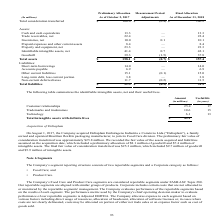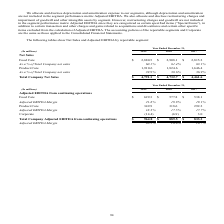From Sealed Air Corporation's financial document, What are the two reportable segments of the company? The document shows two values: Food Care and Product Care. From the document: "• Product Care. lian flexible packaging manufacturer, to join its Food Care division. The preliminary fair value of consideration transferred was appr..." Also, What do the tables show? The following tables show Net Sales and Adjusted EBITDA by reportable segment. The document states: "The following tables show Net Sales and Adjusted EBITDA by reportable segment:..." Also, What is the Adjusted EBITDA Margin for year 2019 for the whole company? According to the financial document, 20.1%. The relevant text states: "Adjusted EBITDA Margin 20.1% 18.8% 18.7%..." Also, can you calculate: What is the average EBITDA Margin for years 2017-2019 for the whole company? To answer this question, I need to perform calculations using the financial data. The calculation is: (20.1+18.8+18.7)/3, which equals 19.2 (percentage). This is based on the information: "Adjusted EBITDA Margin 20.1% 18.8% 18.7% Adjusted EBITDA Margin 20.1% 18.8% 18.7% Adjusted EBITDA Margin 20.1% 18.8% 18.7%..." The key data points involved are: 18.7, 18.8, 20.1. Also, can you calculate: What is the percentage change of  Total Company Net Sales from year 2018 to year 2019? To answer this question, I need to perform calculations using the financial data. The calculation is: (4,791.1-4,732.7)/4,732.7, which equals 1.23 (percentage). This is based on the information: "% 38.6% 36.9% Total Company Net Sales $ 4,791.1 $ 4,732.7 $ 4,461.6 sales 39.9% 38.6% 36.9% Total Company Net Sales $ 4,791.1 $ 4,732.7 $ 4,461.6..." The key data points involved are: 4,732.7, 4,791.1. Also, can you calculate: What is the difference between the growth rate of net sales of Food care as compared to product care from 2017 to 2019? To answer this question, I need to perform calculations using the financial data. The calculation is: (2,880.5-2,815.2)/2,815.2-(1,910.6-1,646.4)/1,646.4, which equals -13.73 (percentage). This is based on the information: "Company net sales 60.1% 61.4% 63.1% Product Care 1,910.6 1,824.6 1,646.4 Food Care $ 2,880.5 $ 2,908.1 $ 2,815.2 es 60.1% 61.4% 63.1% Product Care 1,910.6 1,824.6 1,646.4 Food Care $ 2,880.5 $ 2,908.1..." The key data points involved are: 1,646.4, 1,910.6, 2,815.2. Also, What are the respective net sales for two reportable segments of the company in 2019? The document shows two values: 2,880.5 and 1,910.6 (in millions). From the document: "Company net sales 60.1% 61.4% 63.1% Product Care 1,910.6 1,824.6 1,646.4 Food Care $ 2,880.5 $ 2,908.1 $ 2,815.2..." 